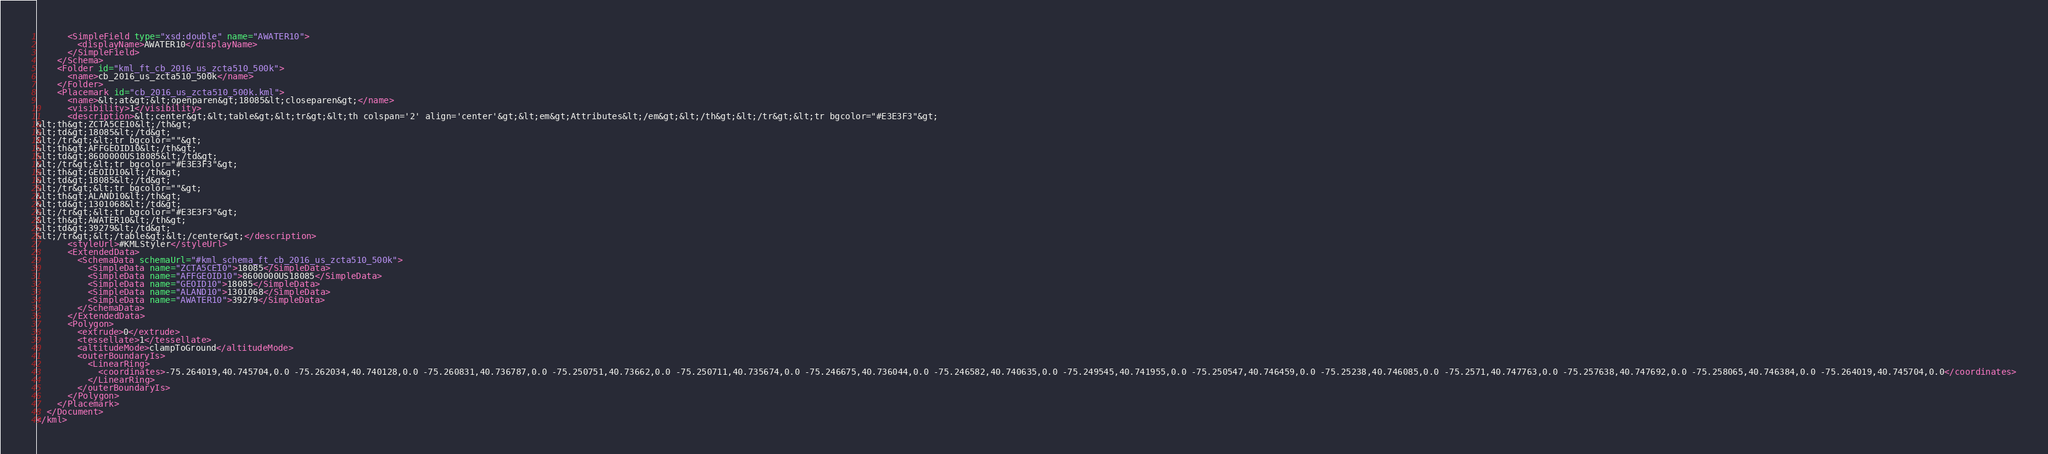Convert code to text. <code><loc_0><loc_0><loc_500><loc_500><_XML_>      <SimpleField type="xsd:double" name="AWATER10">
        <displayName>AWATER10</displayName>
      </SimpleField>
    </Schema>
    <Folder id="kml_ft_cb_2016_us_zcta510_500k">
      <name>cb_2016_us_zcta510_500k</name>
    </Folder>
    <Placemark id="cb_2016_us_zcta510_500k.kml">
      <name>&lt;at&gt;&lt;openparen&gt;18085&lt;closeparen&gt;</name>
      <visibility>1</visibility>
      <description>&lt;center&gt;&lt;table&gt;&lt;tr&gt;&lt;th colspan='2' align='center'&gt;&lt;em&gt;Attributes&lt;/em&gt;&lt;/th&gt;&lt;/tr&gt;&lt;tr bgcolor="#E3E3F3"&gt;
&lt;th&gt;ZCTA5CE10&lt;/th&gt;
&lt;td&gt;18085&lt;/td&gt;
&lt;/tr&gt;&lt;tr bgcolor=""&gt;
&lt;th&gt;AFFGEOID10&lt;/th&gt;
&lt;td&gt;8600000US18085&lt;/td&gt;
&lt;/tr&gt;&lt;tr bgcolor="#E3E3F3"&gt;
&lt;th&gt;GEOID10&lt;/th&gt;
&lt;td&gt;18085&lt;/td&gt;
&lt;/tr&gt;&lt;tr bgcolor=""&gt;
&lt;th&gt;ALAND10&lt;/th&gt;
&lt;td&gt;1301068&lt;/td&gt;
&lt;/tr&gt;&lt;tr bgcolor="#E3E3F3"&gt;
&lt;th&gt;AWATER10&lt;/th&gt;
&lt;td&gt;39279&lt;/td&gt;
&lt;/tr&gt;&lt;/table&gt;&lt;/center&gt;</description>
      <styleUrl>#KMLStyler</styleUrl>
      <ExtendedData>
        <SchemaData schemaUrl="#kml_schema_ft_cb_2016_us_zcta510_500k">
          <SimpleData name="ZCTA5CE10">18085</SimpleData>
          <SimpleData name="AFFGEOID10">8600000US18085</SimpleData>
          <SimpleData name="GEOID10">18085</SimpleData>
          <SimpleData name="ALAND10">1301068</SimpleData>
          <SimpleData name="AWATER10">39279</SimpleData>
        </SchemaData>
      </ExtendedData>
      <Polygon>
        <extrude>0</extrude>
        <tessellate>1</tessellate>
        <altitudeMode>clampToGround</altitudeMode>
        <outerBoundaryIs>
          <LinearRing>
            <coordinates>-75.264019,40.745704,0.0 -75.262034,40.740128,0.0 -75.260831,40.736787,0.0 -75.250751,40.73662,0.0 -75.250711,40.735674,0.0 -75.246675,40.736044,0.0 -75.246582,40.740635,0.0 -75.249545,40.741955,0.0 -75.250547,40.746459,0.0 -75.25238,40.746085,0.0 -75.2571,40.747763,0.0 -75.257638,40.747692,0.0 -75.258065,40.746384,0.0 -75.264019,40.745704,0.0</coordinates>
          </LinearRing>
        </outerBoundaryIs>
      </Polygon>
    </Placemark>
  </Document>
</kml></code> 